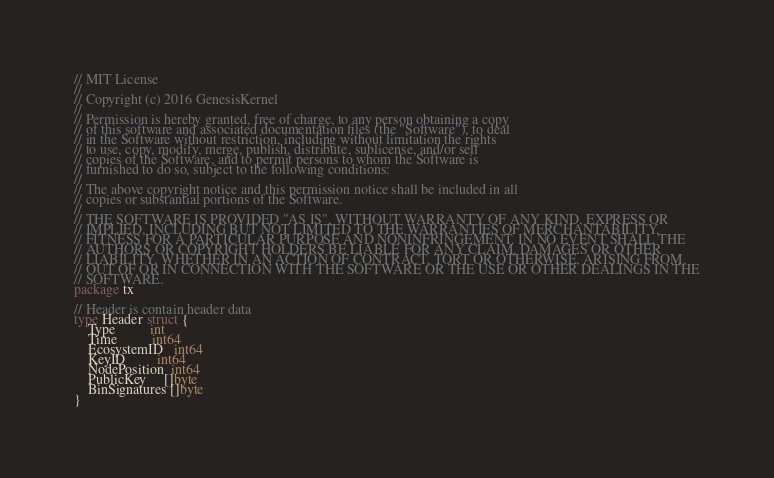<code> <loc_0><loc_0><loc_500><loc_500><_Go_>// MIT License
//
// Copyright (c) 2016 GenesisKernel
//
// Permission is hereby granted, free of charge, to any person obtaining a copy
// of this software and associated documentation files (the "Software"), to deal
// in the Software without restriction, including without limitation the rights
// to use, copy, modify, merge, publish, distribute, sublicense, and/or sell
// copies of the Software, and to permit persons to whom the Software is
// furnished to do so, subject to the following conditions:
//
// The above copyright notice and this permission notice shall be included in all
// copies or substantial portions of the Software.
//
// THE SOFTWARE IS PROVIDED "AS IS", WITHOUT WARRANTY OF ANY KIND, EXPRESS OR
// IMPLIED, INCLUDING BUT NOT LIMITED TO THE WARRANTIES OF MERCHANTABILITY,
// FITNESS FOR A PARTICULAR PURPOSE AND NONINFRINGEMENT. IN NO EVENT SHALL THE
// AUTHORS OR COPYRIGHT HOLDERS BE LIABLE FOR ANY CLAIM, DAMAGES OR OTHER
// LIABILITY, WHETHER IN AN ACTION OF CONTRACT, TORT OR OTHERWISE, ARISING FROM,
// OUT OF OR IN CONNECTION WITH THE SOFTWARE OR THE USE OR OTHER DEALINGS IN THE
// SOFTWARE.
package tx

// Header is contain header data
type Header struct {
	Type          int
	Time          int64
	EcosystemID   int64
	KeyID         int64
	NodePosition  int64
	PublicKey     []byte
	BinSignatures []byte
}
</code> 